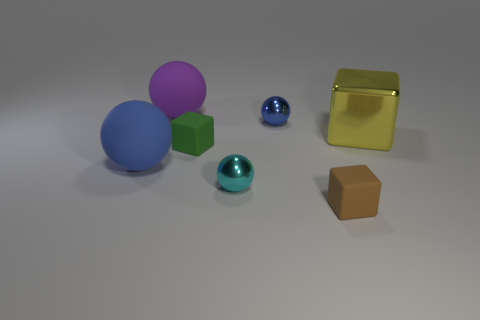What textures can you see on the objects, and how might those textures affect the way light interacts with their surfaces? The objects exhibit a variety of textures. The spheres and the small cube appear smooth, which allows for even reflection of light. The gold cube has a reflective metallic surface that mirrors its environment clearly, while the green and brown cubes seem to have a matte finish, diffusing light softly without reflection. Is there any pattern in the arrangement of the objects? There isn't a discernible pattern in the arrangement, but the objects are spaced out in a way that neither seems random nor ordered. They are laid out in a somewhat linear fashion with varied spacing. 